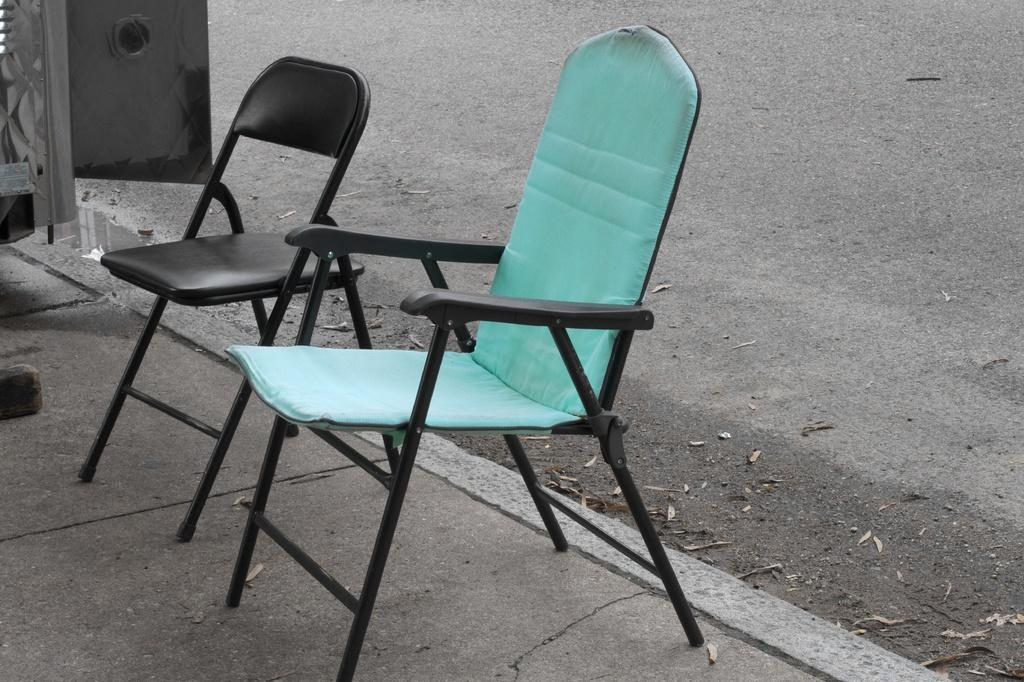How many chairs are in the image? There are two chairs in the image. Where are the chairs located? The chairs are on a platform. What can be seen in the background of the image? There is a road visible in the background of the image. What is the name of the person sitting on the left chair in the image? There are no people visible in the image, so it is not possible to determine the name of anyone sitting on a chair. 